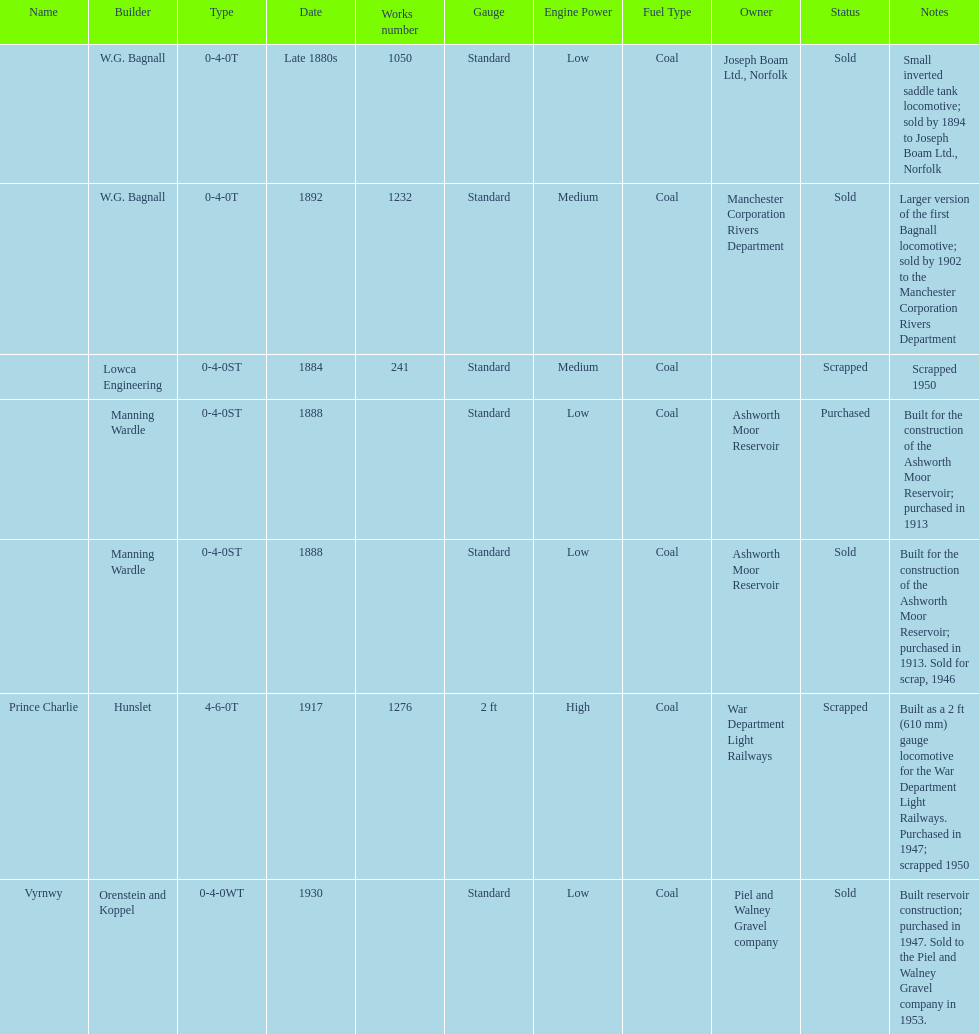Who built the larger version of the first bagnall locomotive? W.G. Bagnall. 